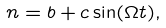<formula> <loc_0><loc_0><loc_500><loc_500>n = b + c \sin ( \Omega t ) ,</formula> 